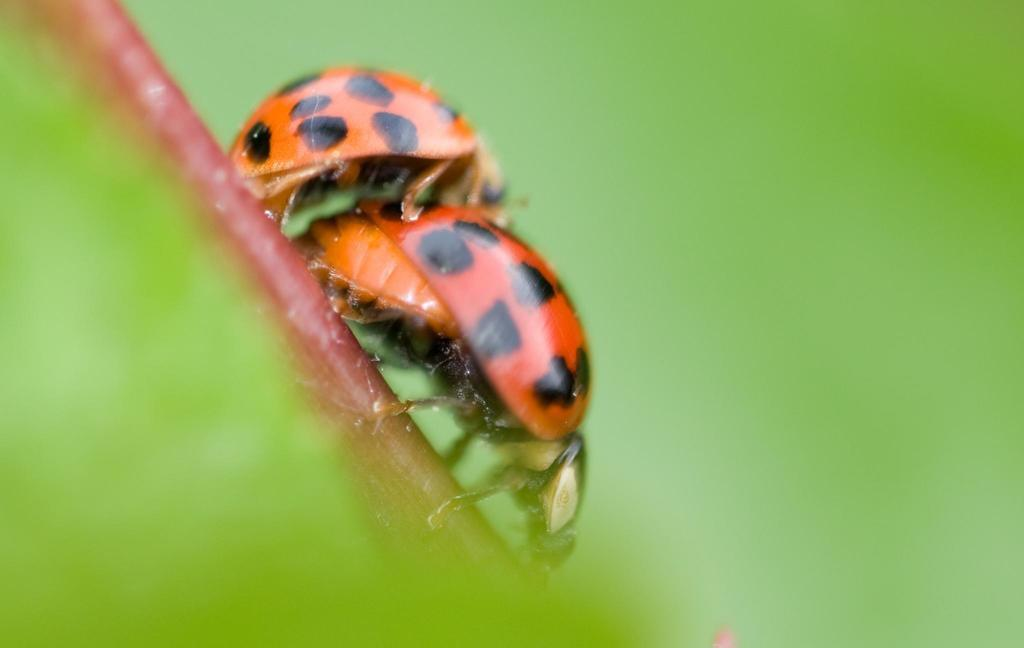What type of living organisms can be seen on the plant stem in the image? There are insects on a plant stem in the image. Can you describe the background of the image? The background of the image is blurred. What type of ball can be seen being kicked in the image? There is no ball or kicking activity present in the image. What type of food is visible in the image? There is no food visible in the image. 